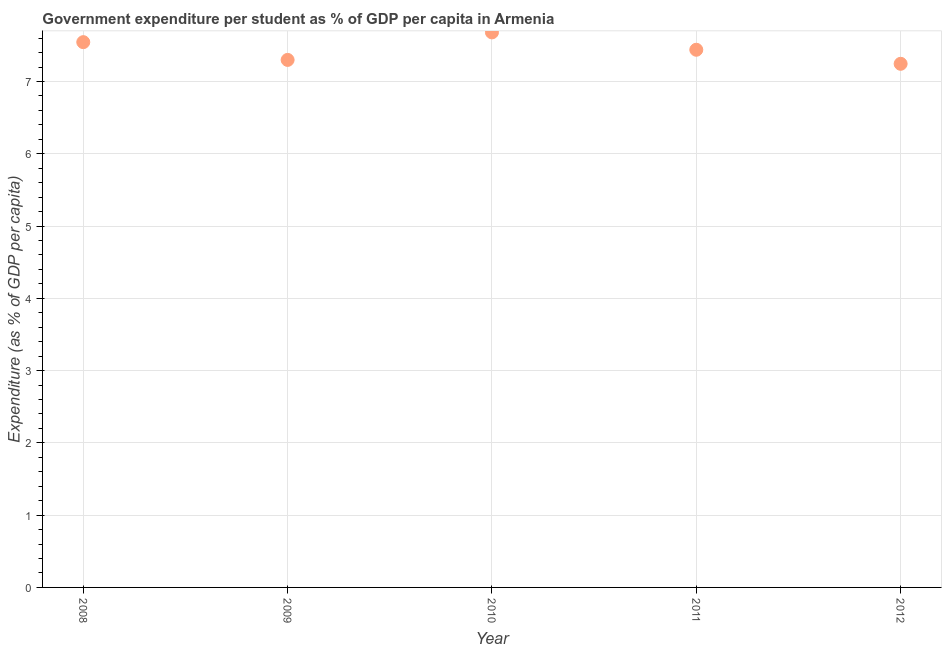What is the government expenditure per student in 2008?
Your answer should be compact. 7.54. Across all years, what is the maximum government expenditure per student?
Make the answer very short. 7.68. Across all years, what is the minimum government expenditure per student?
Ensure brevity in your answer.  7.24. In which year was the government expenditure per student maximum?
Ensure brevity in your answer.  2010. In which year was the government expenditure per student minimum?
Your answer should be compact. 2012. What is the sum of the government expenditure per student?
Provide a short and direct response. 37.2. What is the difference between the government expenditure per student in 2009 and 2010?
Offer a very short reply. -0.38. What is the average government expenditure per student per year?
Give a very brief answer. 7.44. What is the median government expenditure per student?
Provide a succinct answer. 7.44. In how many years, is the government expenditure per student greater than 6.4 %?
Your response must be concise. 5. Do a majority of the years between 2012 and 2010 (inclusive) have government expenditure per student greater than 4.2 %?
Keep it short and to the point. No. What is the ratio of the government expenditure per student in 2008 to that in 2011?
Offer a terse response. 1.01. What is the difference between the highest and the second highest government expenditure per student?
Ensure brevity in your answer.  0.13. What is the difference between the highest and the lowest government expenditure per student?
Your response must be concise. 0.43. In how many years, is the government expenditure per student greater than the average government expenditure per student taken over all years?
Offer a very short reply. 2. How many years are there in the graph?
Your answer should be compact. 5. What is the difference between two consecutive major ticks on the Y-axis?
Keep it short and to the point. 1. Are the values on the major ticks of Y-axis written in scientific E-notation?
Make the answer very short. No. What is the title of the graph?
Give a very brief answer. Government expenditure per student as % of GDP per capita in Armenia. What is the label or title of the Y-axis?
Your response must be concise. Expenditure (as % of GDP per capita). What is the Expenditure (as % of GDP per capita) in 2008?
Offer a terse response. 7.54. What is the Expenditure (as % of GDP per capita) in 2009?
Give a very brief answer. 7.3. What is the Expenditure (as % of GDP per capita) in 2010?
Provide a short and direct response. 7.68. What is the Expenditure (as % of GDP per capita) in 2011?
Offer a terse response. 7.44. What is the Expenditure (as % of GDP per capita) in 2012?
Offer a terse response. 7.24. What is the difference between the Expenditure (as % of GDP per capita) in 2008 and 2009?
Offer a terse response. 0.25. What is the difference between the Expenditure (as % of GDP per capita) in 2008 and 2010?
Ensure brevity in your answer.  -0.14. What is the difference between the Expenditure (as % of GDP per capita) in 2008 and 2011?
Keep it short and to the point. 0.11. What is the difference between the Expenditure (as % of GDP per capita) in 2008 and 2012?
Your response must be concise. 0.3. What is the difference between the Expenditure (as % of GDP per capita) in 2009 and 2010?
Offer a very short reply. -0.38. What is the difference between the Expenditure (as % of GDP per capita) in 2009 and 2011?
Ensure brevity in your answer.  -0.14. What is the difference between the Expenditure (as % of GDP per capita) in 2009 and 2012?
Give a very brief answer. 0.05. What is the difference between the Expenditure (as % of GDP per capita) in 2010 and 2011?
Provide a succinct answer. 0.24. What is the difference between the Expenditure (as % of GDP per capita) in 2010 and 2012?
Give a very brief answer. 0.43. What is the difference between the Expenditure (as % of GDP per capita) in 2011 and 2012?
Offer a very short reply. 0.19. What is the ratio of the Expenditure (as % of GDP per capita) in 2008 to that in 2009?
Give a very brief answer. 1.03. What is the ratio of the Expenditure (as % of GDP per capita) in 2008 to that in 2010?
Keep it short and to the point. 0.98. What is the ratio of the Expenditure (as % of GDP per capita) in 2008 to that in 2012?
Your answer should be very brief. 1.04. What is the ratio of the Expenditure (as % of GDP per capita) in 2009 to that in 2012?
Offer a very short reply. 1.01. What is the ratio of the Expenditure (as % of GDP per capita) in 2010 to that in 2011?
Provide a succinct answer. 1.03. What is the ratio of the Expenditure (as % of GDP per capita) in 2010 to that in 2012?
Your response must be concise. 1.06. 